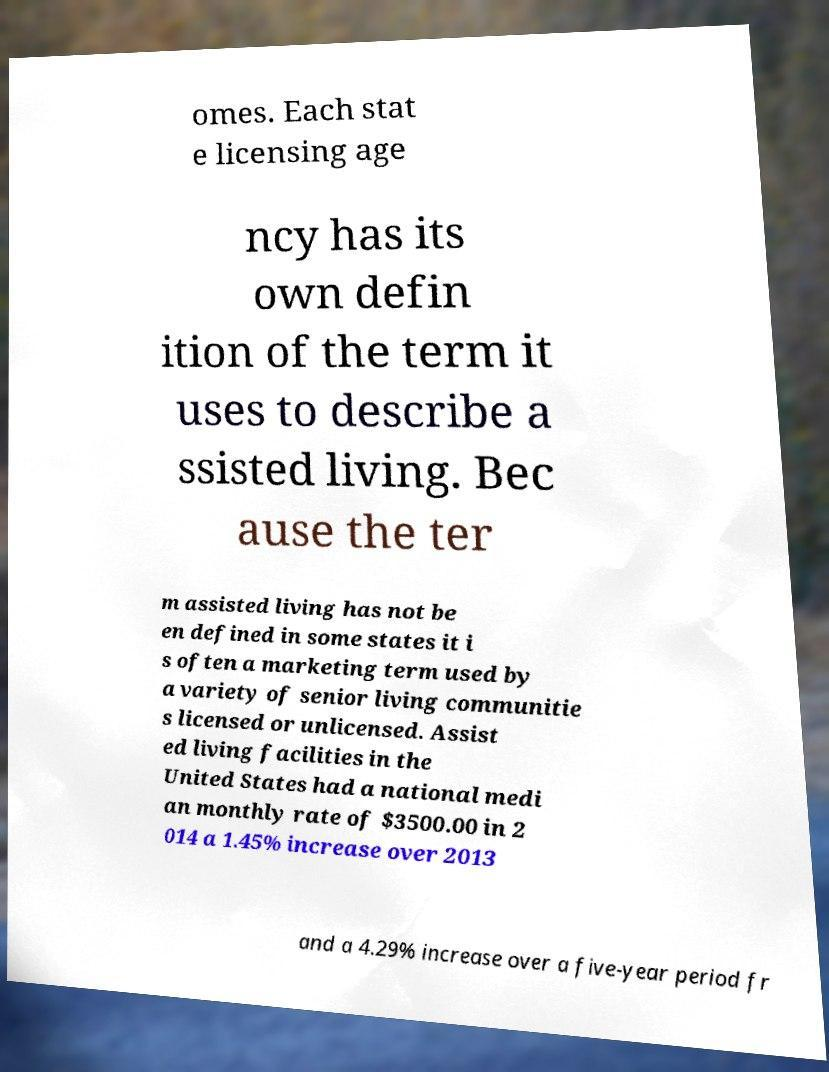Can you read and provide the text displayed in the image?This photo seems to have some interesting text. Can you extract and type it out for me? omes. Each stat e licensing age ncy has its own defin ition of the term it uses to describe a ssisted living. Bec ause the ter m assisted living has not be en defined in some states it i s often a marketing term used by a variety of senior living communitie s licensed or unlicensed. Assist ed living facilities in the United States had a national medi an monthly rate of $3500.00 in 2 014 a 1.45% increase over 2013 and a 4.29% increase over a five-year period fr 